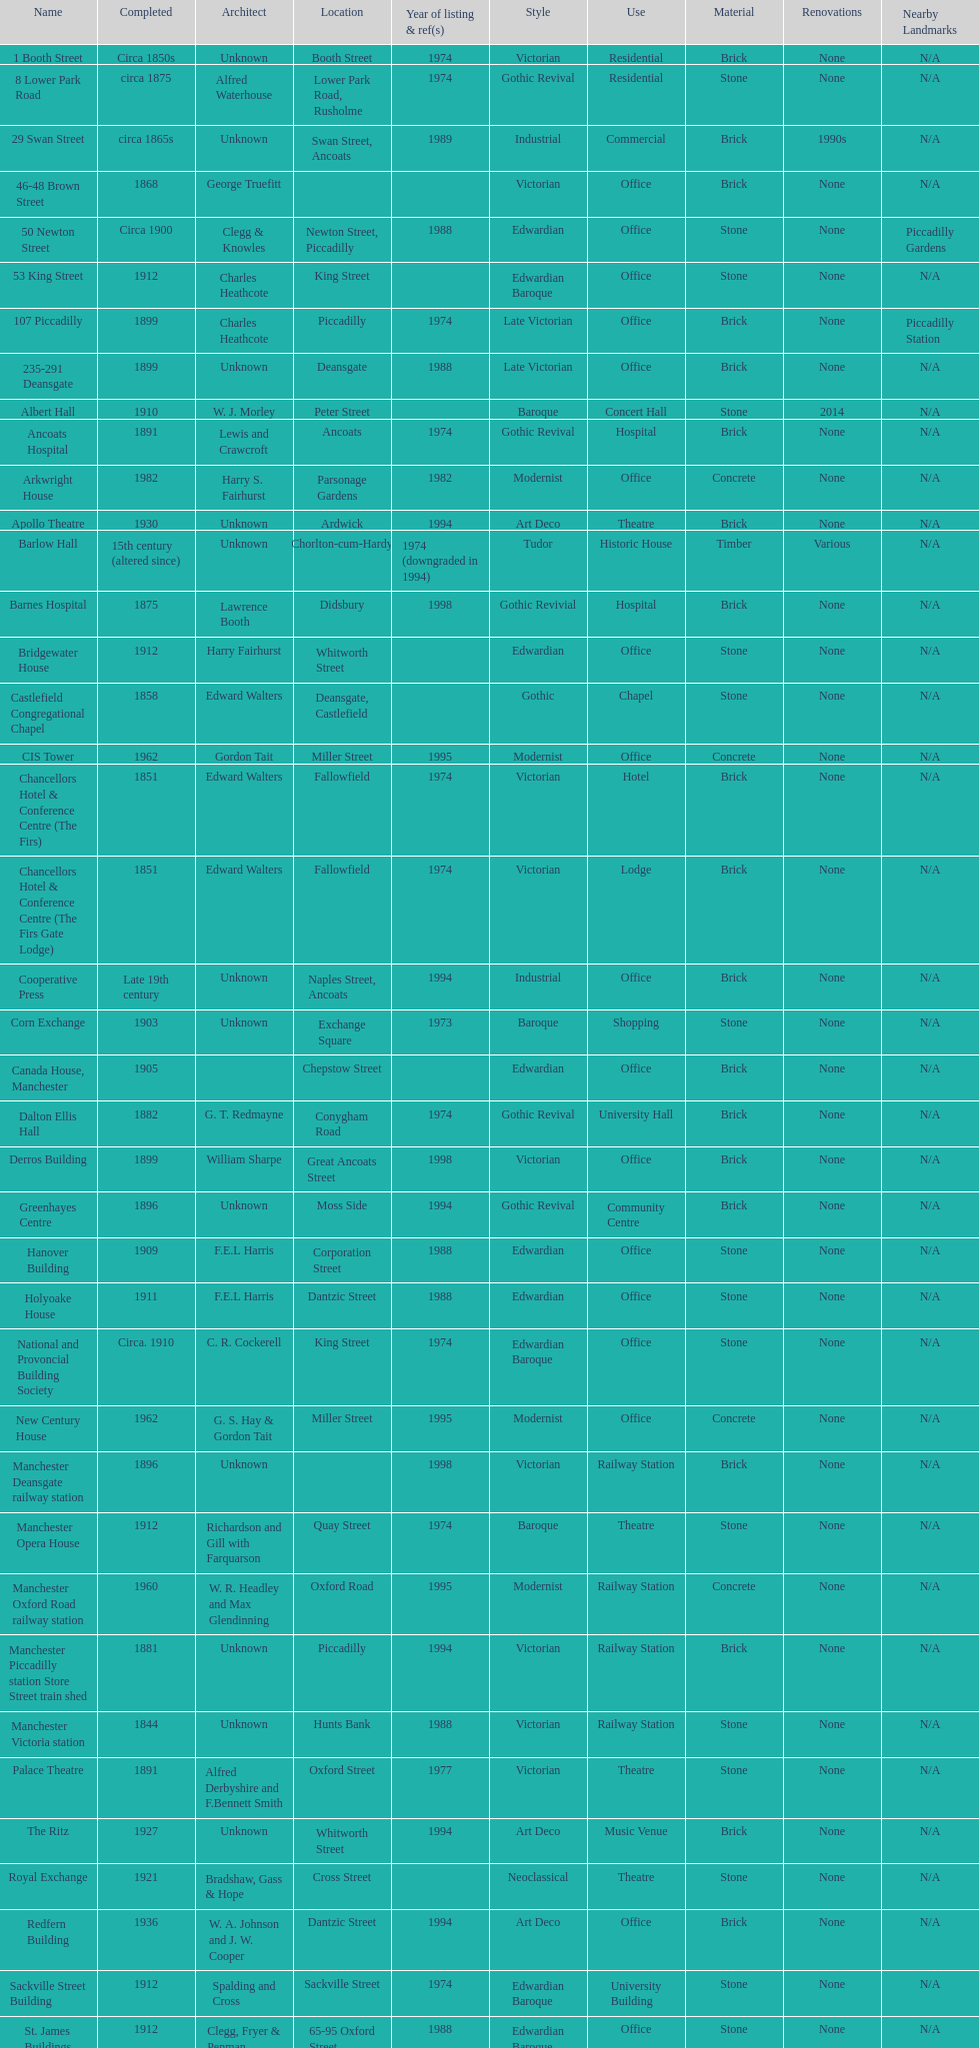Which year has the most buildings listed? 1974. 